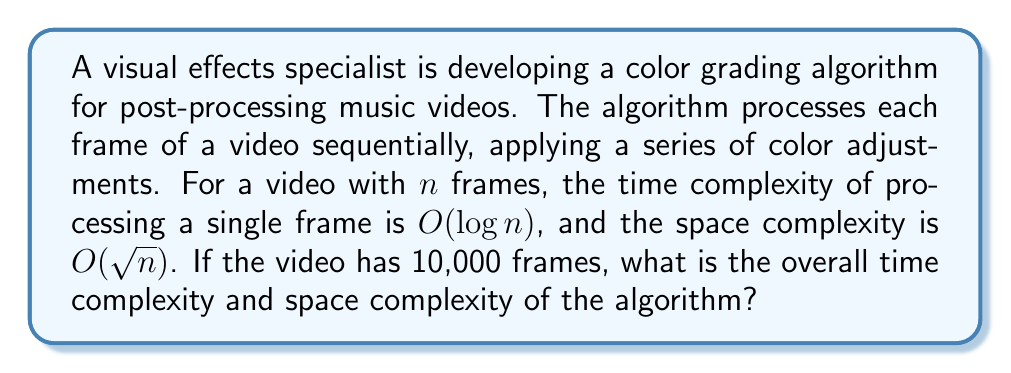What is the answer to this math problem? To determine the overall time and space complexity, we need to consider how the algorithm scales with the input size (number of frames).

Time Complexity:
1. For each frame, the processing time is $O(\log n)$
2. There are $n$ frames in total
3. The algorithm processes all frames sequentially

Thus, the overall time complexity is:
$$T(n) = n \cdot O(\log n) = O(n \log n)$$

Space Complexity:
1. The space complexity for processing a single frame is $O(\sqrt{n})$
2. Since frames are processed sequentially, we only need to consider the space used for one frame at a time
3. The space complexity doesn't accumulate across frames

Therefore, the overall space complexity remains:
$$S(n) = O(\sqrt{n})$$

For the specific case of 10,000 frames:
$$n = 10,000$$

The time complexity would be $O(10,000 \log 10,000)$, and the space complexity would be $O(\sqrt{10,000})$.
Answer: Time Complexity: $O(n \log n)$
Space Complexity: $O(\sqrt{n})$ 